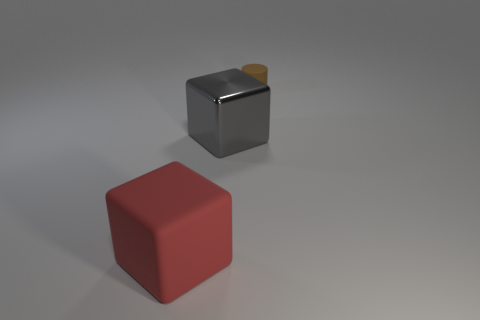Add 1 tiny brown cylinders. How many objects exist? 4 Subtract all gray blocks. How many blocks are left? 1 Subtract all cubes. How many objects are left? 1 Subtract 1 cylinders. How many cylinders are left? 0 Subtract all purple cubes. Subtract all blue spheres. How many cubes are left? 2 Subtract all cyan cubes. How many gray cylinders are left? 0 Subtract all red rubber cylinders. Subtract all large red matte objects. How many objects are left? 2 Add 2 rubber things. How many rubber things are left? 4 Add 1 big gray blocks. How many big gray blocks exist? 2 Subtract 0 brown balls. How many objects are left? 3 